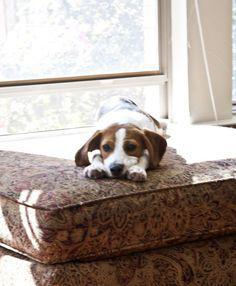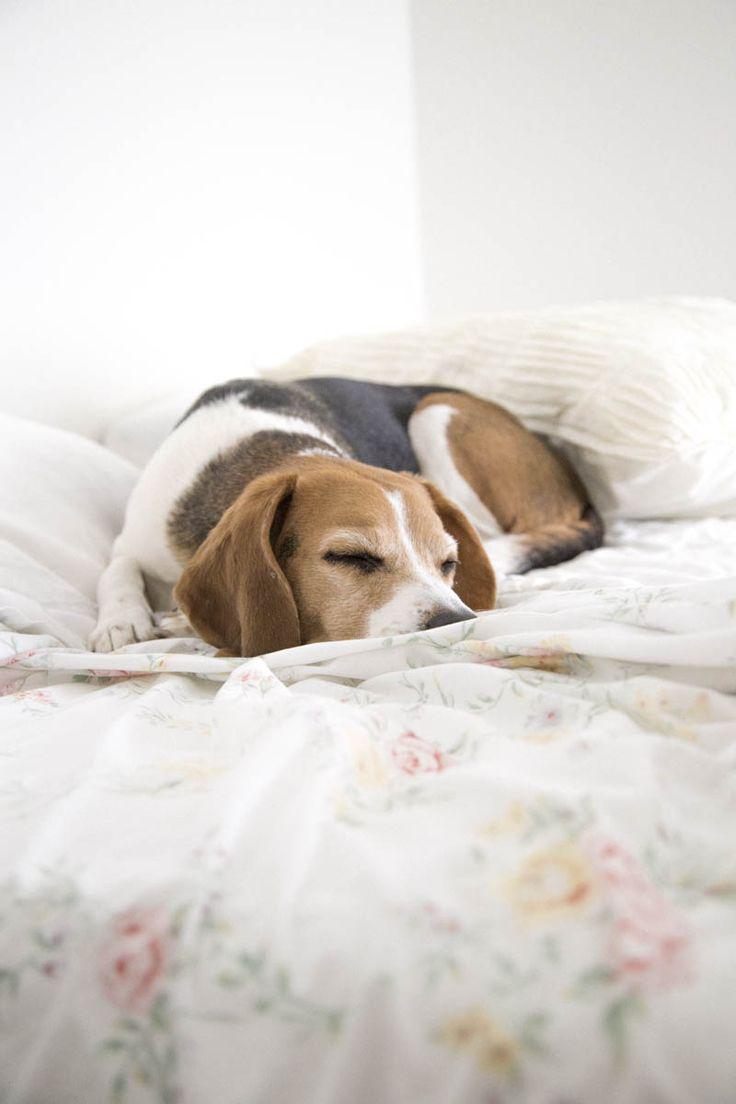The first image is the image on the left, the second image is the image on the right. Assess this claim about the two images: "In one of the images there is a beagle in the sitting position.". Correct or not? Answer yes or no. No. The first image is the image on the left, the second image is the image on the right. Assess this claim about the two images: "At least one of the puppies is real and is sitting down.". Correct or not? Answer yes or no. No. 